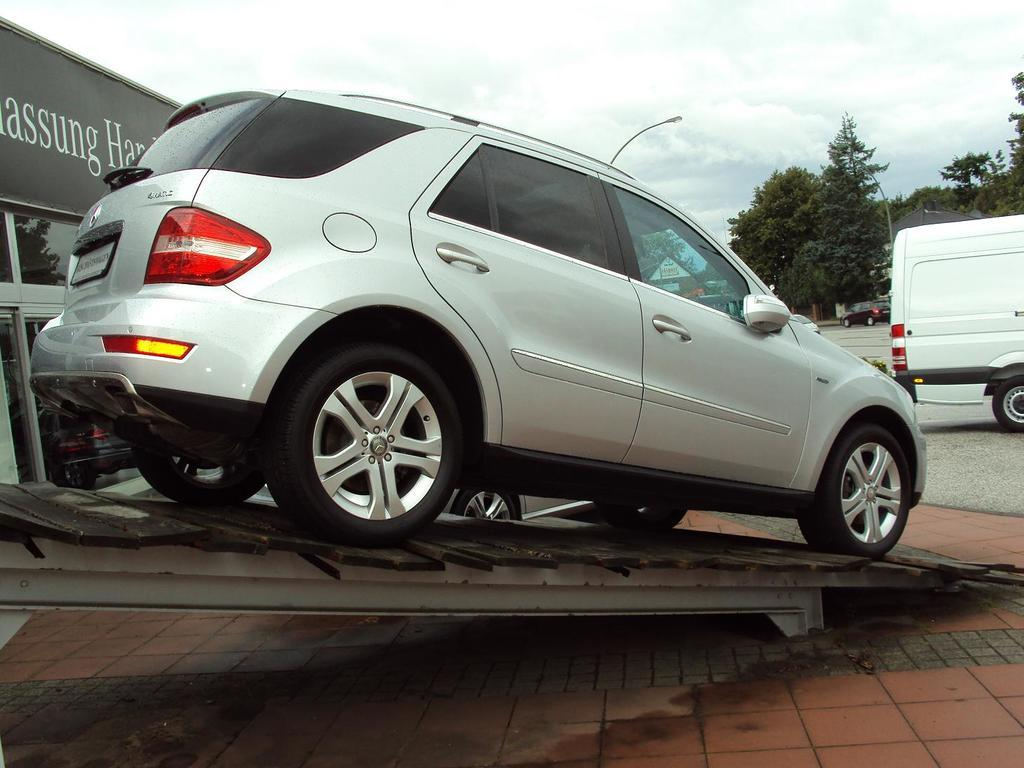What types of vehicles can be seen in the image? There are vehicles in the image, but the specific types are not mentioned. What is the car doing in the image? The car is on a ramp in the image. What can be seen in the background of the image? There are trees, poles, and a building in the background of the image. How many people are in the crowd in the image? There is no crowd present in the image. What fact about the home can be seen in the image? There is no home present in the image. 